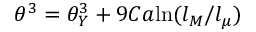Convert formula to latex. <formula><loc_0><loc_0><loc_500><loc_500>\theta ^ { 3 } = \theta _ { Y } ^ { 3 } + 9 C a \ln ( l _ { M } / l _ { \mu } )</formula> 